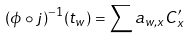<formula> <loc_0><loc_0><loc_500><loc_500>( \phi \circ j ) ^ { - 1 } ( t _ { w } ) = \sum a _ { w , x } C ^ { \prime } _ { x }</formula> 